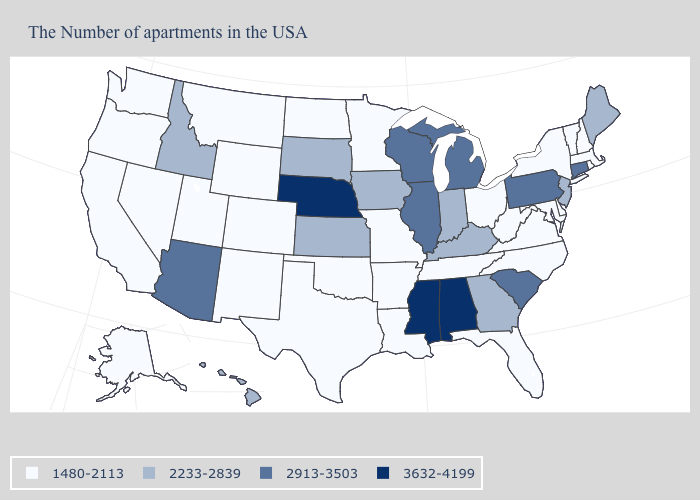Which states hav the highest value in the West?
Be succinct. Arizona. Name the states that have a value in the range 2233-2839?
Write a very short answer. Maine, New Jersey, Georgia, Kentucky, Indiana, Iowa, Kansas, South Dakota, Idaho, Hawaii. Name the states that have a value in the range 1480-2113?
Concise answer only. Massachusetts, Rhode Island, New Hampshire, Vermont, New York, Delaware, Maryland, Virginia, North Carolina, West Virginia, Ohio, Florida, Tennessee, Louisiana, Missouri, Arkansas, Minnesota, Oklahoma, Texas, North Dakota, Wyoming, Colorado, New Mexico, Utah, Montana, Nevada, California, Washington, Oregon, Alaska. Among the states that border North Carolina , which have the highest value?
Be succinct. South Carolina. Which states hav the highest value in the West?
Give a very brief answer. Arizona. What is the lowest value in states that border Virginia?
Keep it brief. 1480-2113. Does the first symbol in the legend represent the smallest category?
Short answer required. Yes. Among the states that border Ohio , does Kentucky have the highest value?
Concise answer only. No. Does the first symbol in the legend represent the smallest category?
Keep it brief. Yes. What is the value of Connecticut?
Answer briefly. 2913-3503. What is the lowest value in the USA?
Give a very brief answer. 1480-2113. What is the highest value in the USA?
Be succinct. 3632-4199. Is the legend a continuous bar?
Concise answer only. No. What is the value of Hawaii?
Keep it brief. 2233-2839. Name the states that have a value in the range 2913-3503?
Be succinct. Connecticut, Pennsylvania, South Carolina, Michigan, Wisconsin, Illinois, Arizona. 